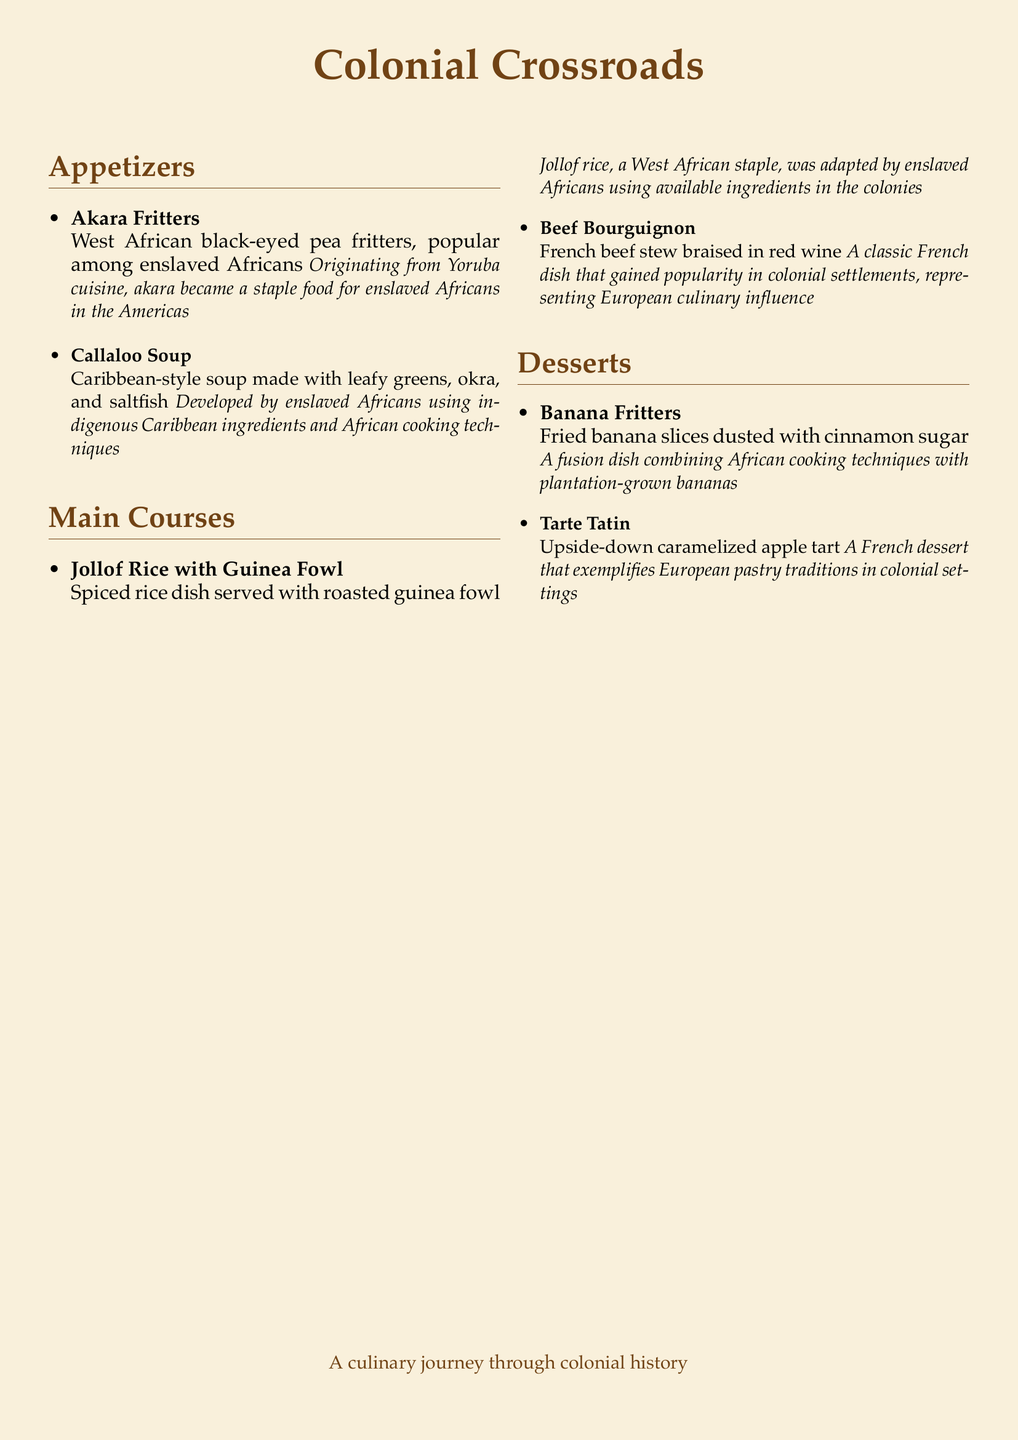what is the name of the restaurant? The name of the restaurant is mentioned at the top of the document as "Colonial Crossroads."
Answer: Colonial Crossroads how many sections are in the menu? The document has three sections: Appetizers, Main Courses, and Desserts.
Answer: 3 what dish uses black-eyed peas? The dish that uses black-eyed peas is noted as "Akara Fritters."
Answer: Akara Fritters which dish represents European culinary influence? The dish that represents European culinary influence is "Beef Bourguignon."
Answer: Beef Bourguignon what is the main ingredient in Callaloo Soup? The main ingredient in Callaloo Soup is leafy greens.
Answer: leafy greens which cooking technique is highlighted in the dessert Banana Fritters? The cooking technique highlighted in the dish "Banana Fritters" is frying.
Answer: frying what type of meat is served with Jollof Rice? The type of meat served with Jollof Rice is guinea fowl.
Answer: guinea fowl who developed Callaloo Soup? The dish Callaloo Soup was developed by enslaved Africans.
Answer: enslaved Africans what is the origin of Akara Fritters? The origin of Akara Fritters is Yoruba cuisine.
Answer: Yoruba cuisine 